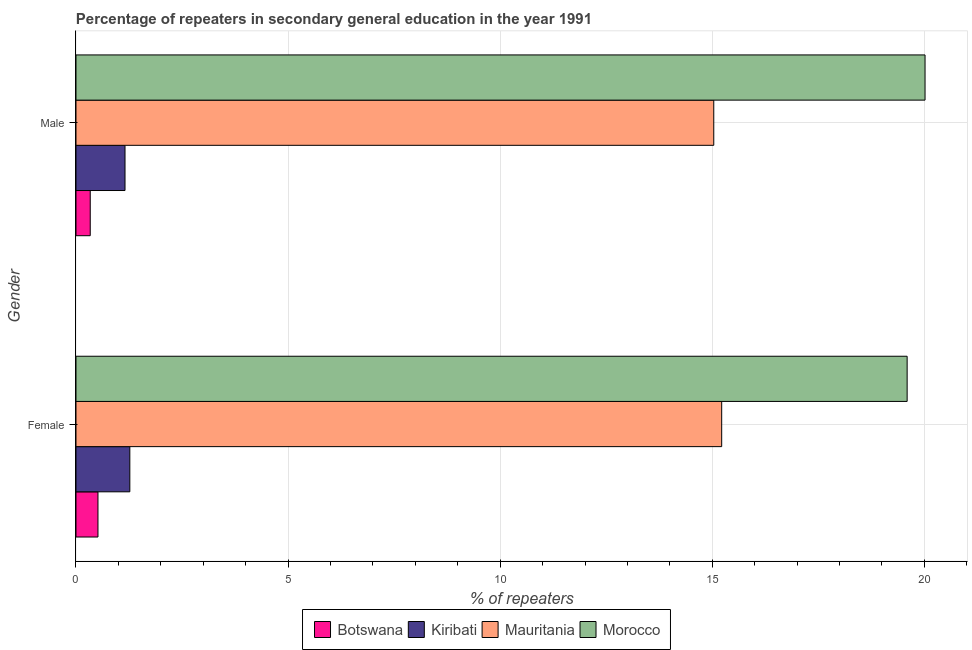Are the number of bars on each tick of the Y-axis equal?
Your answer should be very brief. Yes. What is the label of the 1st group of bars from the top?
Your response must be concise. Male. What is the percentage of female repeaters in Morocco?
Provide a succinct answer. 19.59. Across all countries, what is the maximum percentage of male repeaters?
Your response must be concise. 20.01. Across all countries, what is the minimum percentage of female repeaters?
Keep it short and to the point. 0.52. In which country was the percentage of male repeaters maximum?
Your answer should be very brief. Morocco. In which country was the percentage of female repeaters minimum?
Make the answer very short. Botswana. What is the total percentage of female repeaters in the graph?
Offer a terse response. 36.6. What is the difference between the percentage of male repeaters in Mauritania and that in Kiribati?
Provide a succinct answer. 13.88. What is the difference between the percentage of female repeaters in Kiribati and the percentage of male repeaters in Mauritania?
Provide a short and direct response. -13.77. What is the average percentage of male repeaters per country?
Make the answer very short. 9.14. What is the difference between the percentage of female repeaters and percentage of male repeaters in Morocco?
Offer a terse response. -0.42. What is the ratio of the percentage of female repeaters in Mauritania to that in Botswana?
Give a very brief answer. 29.38. In how many countries, is the percentage of female repeaters greater than the average percentage of female repeaters taken over all countries?
Offer a terse response. 2. What does the 4th bar from the top in Female represents?
Provide a short and direct response. Botswana. What does the 4th bar from the bottom in Female represents?
Provide a succinct answer. Morocco. Does the graph contain grids?
Your response must be concise. Yes. How are the legend labels stacked?
Make the answer very short. Horizontal. What is the title of the graph?
Your answer should be compact. Percentage of repeaters in secondary general education in the year 1991. What is the label or title of the X-axis?
Make the answer very short. % of repeaters. What is the label or title of the Y-axis?
Offer a terse response. Gender. What is the % of repeaters in Botswana in Female?
Offer a terse response. 0.52. What is the % of repeaters of Kiribati in Female?
Provide a short and direct response. 1.27. What is the % of repeaters of Mauritania in Female?
Provide a succinct answer. 15.22. What is the % of repeaters in Morocco in Female?
Offer a very short reply. 19.59. What is the % of repeaters in Botswana in Male?
Make the answer very short. 0.34. What is the % of repeaters of Kiribati in Male?
Your answer should be compact. 1.16. What is the % of repeaters of Mauritania in Male?
Your answer should be very brief. 15.03. What is the % of repeaters in Morocco in Male?
Your response must be concise. 20.01. Across all Gender, what is the maximum % of repeaters of Botswana?
Give a very brief answer. 0.52. Across all Gender, what is the maximum % of repeaters in Kiribati?
Offer a terse response. 1.27. Across all Gender, what is the maximum % of repeaters in Mauritania?
Offer a terse response. 15.22. Across all Gender, what is the maximum % of repeaters in Morocco?
Your answer should be very brief. 20.01. Across all Gender, what is the minimum % of repeaters in Botswana?
Your answer should be compact. 0.34. Across all Gender, what is the minimum % of repeaters in Kiribati?
Provide a succinct answer. 1.16. Across all Gender, what is the minimum % of repeaters in Mauritania?
Make the answer very short. 15.03. Across all Gender, what is the minimum % of repeaters of Morocco?
Offer a terse response. 19.59. What is the total % of repeaters of Botswana in the graph?
Give a very brief answer. 0.85. What is the total % of repeaters of Kiribati in the graph?
Provide a succinct answer. 2.42. What is the total % of repeaters of Mauritania in the graph?
Your answer should be very brief. 30.26. What is the total % of repeaters of Morocco in the graph?
Ensure brevity in your answer.  39.61. What is the difference between the % of repeaters of Botswana in Female and that in Male?
Provide a short and direct response. 0.18. What is the difference between the % of repeaters in Kiribati in Female and that in Male?
Offer a very short reply. 0.11. What is the difference between the % of repeaters in Mauritania in Female and that in Male?
Make the answer very short. 0.19. What is the difference between the % of repeaters in Morocco in Female and that in Male?
Offer a terse response. -0.42. What is the difference between the % of repeaters in Botswana in Female and the % of repeaters in Kiribati in Male?
Offer a terse response. -0.64. What is the difference between the % of repeaters in Botswana in Female and the % of repeaters in Mauritania in Male?
Your response must be concise. -14.52. What is the difference between the % of repeaters in Botswana in Female and the % of repeaters in Morocco in Male?
Your answer should be compact. -19.5. What is the difference between the % of repeaters of Kiribati in Female and the % of repeaters of Mauritania in Male?
Provide a short and direct response. -13.77. What is the difference between the % of repeaters in Kiribati in Female and the % of repeaters in Morocco in Male?
Provide a short and direct response. -18.75. What is the difference between the % of repeaters in Mauritania in Female and the % of repeaters in Morocco in Male?
Offer a very short reply. -4.79. What is the average % of repeaters in Botswana per Gender?
Offer a terse response. 0.43. What is the average % of repeaters in Kiribati per Gender?
Give a very brief answer. 1.21. What is the average % of repeaters of Mauritania per Gender?
Your response must be concise. 15.13. What is the average % of repeaters of Morocco per Gender?
Ensure brevity in your answer.  19.8. What is the difference between the % of repeaters of Botswana and % of repeaters of Kiribati in Female?
Provide a succinct answer. -0.75. What is the difference between the % of repeaters in Botswana and % of repeaters in Mauritania in Female?
Provide a short and direct response. -14.7. What is the difference between the % of repeaters of Botswana and % of repeaters of Morocco in Female?
Provide a short and direct response. -19.08. What is the difference between the % of repeaters of Kiribati and % of repeaters of Mauritania in Female?
Make the answer very short. -13.95. What is the difference between the % of repeaters of Kiribati and % of repeaters of Morocco in Female?
Provide a short and direct response. -18.32. What is the difference between the % of repeaters in Mauritania and % of repeaters in Morocco in Female?
Your response must be concise. -4.37. What is the difference between the % of repeaters of Botswana and % of repeaters of Kiribati in Male?
Make the answer very short. -0.82. What is the difference between the % of repeaters in Botswana and % of repeaters in Mauritania in Male?
Give a very brief answer. -14.7. What is the difference between the % of repeaters of Botswana and % of repeaters of Morocco in Male?
Make the answer very short. -19.68. What is the difference between the % of repeaters of Kiribati and % of repeaters of Mauritania in Male?
Offer a very short reply. -13.88. What is the difference between the % of repeaters of Kiribati and % of repeaters of Morocco in Male?
Keep it short and to the point. -18.86. What is the difference between the % of repeaters in Mauritania and % of repeaters in Morocco in Male?
Ensure brevity in your answer.  -4.98. What is the ratio of the % of repeaters of Botswana in Female to that in Male?
Your answer should be very brief. 1.54. What is the ratio of the % of repeaters of Kiribati in Female to that in Male?
Make the answer very short. 1.1. What is the ratio of the % of repeaters of Mauritania in Female to that in Male?
Give a very brief answer. 1.01. What is the ratio of the % of repeaters of Morocco in Female to that in Male?
Your answer should be compact. 0.98. What is the difference between the highest and the second highest % of repeaters in Botswana?
Your response must be concise. 0.18. What is the difference between the highest and the second highest % of repeaters of Kiribati?
Offer a terse response. 0.11. What is the difference between the highest and the second highest % of repeaters of Mauritania?
Provide a short and direct response. 0.19. What is the difference between the highest and the second highest % of repeaters of Morocco?
Offer a very short reply. 0.42. What is the difference between the highest and the lowest % of repeaters of Botswana?
Your response must be concise. 0.18. What is the difference between the highest and the lowest % of repeaters in Kiribati?
Give a very brief answer. 0.11. What is the difference between the highest and the lowest % of repeaters in Mauritania?
Provide a succinct answer. 0.19. What is the difference between the highest and the lowest % of repeaters in Morocco?
Offer a terse response. 0.42. 